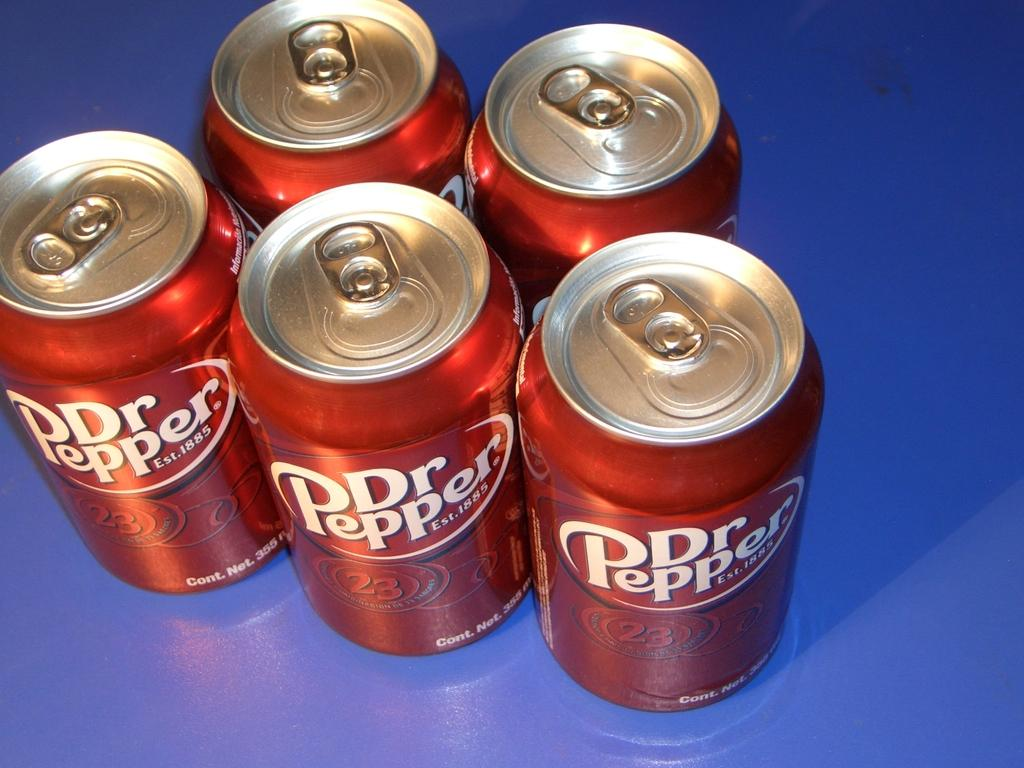<image>
Relay a brief, clear account of the picture shown. some Dr. Pepper cans that are grouped together 